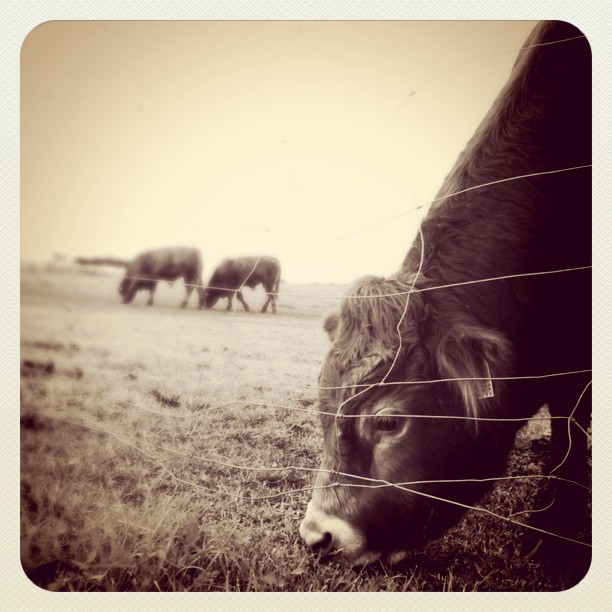Describe the mood of this photograph. The photograph evokes a serene and peaceful mood, emphasized by the monochromatic tones and soft focus. The cattle’s calm grazing and the open field contribute to a sense of simplicity and timelessness. 